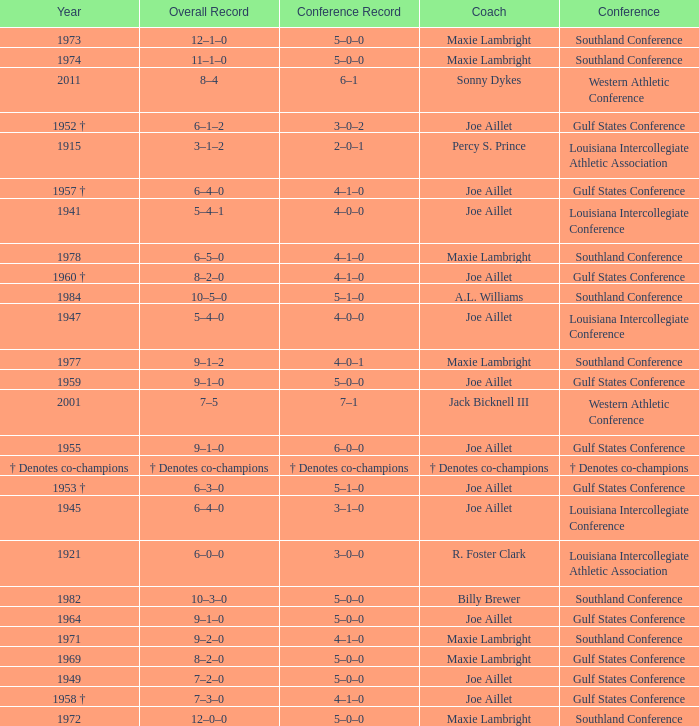What is the conference record for the year of 1971? 4–1–0. 